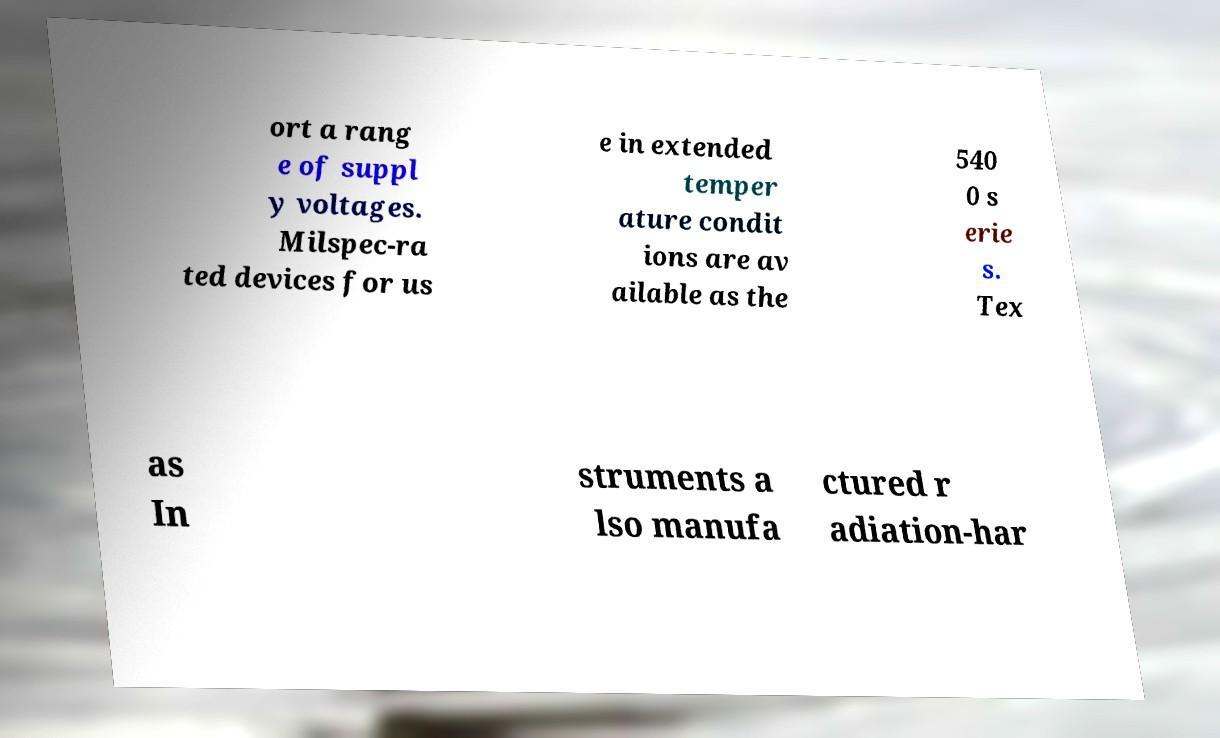For documentation purposes, I need the text within this image transcribed. Could you provide that? ort a rang e of suppl y voltages. Milspec-ra ted devices for us e in extended temper ature condit ions are av ailable as the 540 0 s erie s. Tex as In struments a lso manufa ctured r adiation-har 